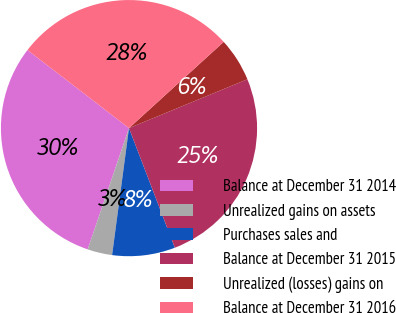Convert chart to OTSL. <chart><loc_0><loc_0><loc_500><loc_500><pie_chart><fcel>Balance at December 31 2014<fcel>Unrealized gains on assets<fcel>Purchases sales and<fcel>Balance at December 31 2015<fcel>Unrealized (losses) gains on<fcel>Balance at December 31 2016<nl><fcel>30.21%<fcel>3.12%<fcel>7.93%<fcel>25.4%<fcel>5.53%<fcel>27.81%<nl></chart> 